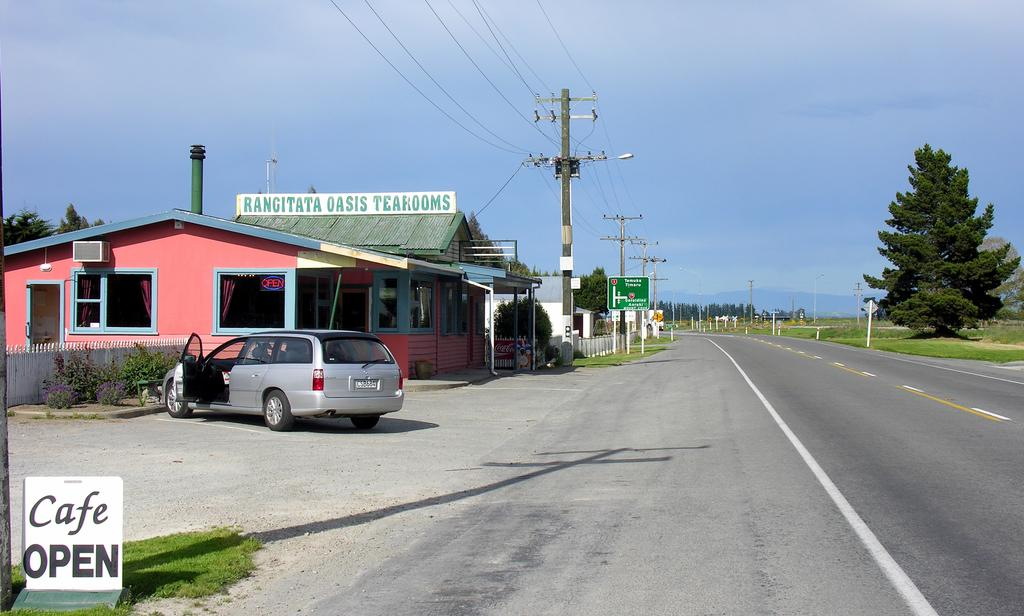What is the main subject of the image? There is a car in the image. What other objects can be seen in the image? There are boards, poles, trees, grass, a fence, plants, houses, and a road visible in the image. What is the background of the image? The sky is visible in the background of the image. What type of jelly is being used to frame the car in the image? There is no jelly present in the image, and the car is not framed by any jelly. 